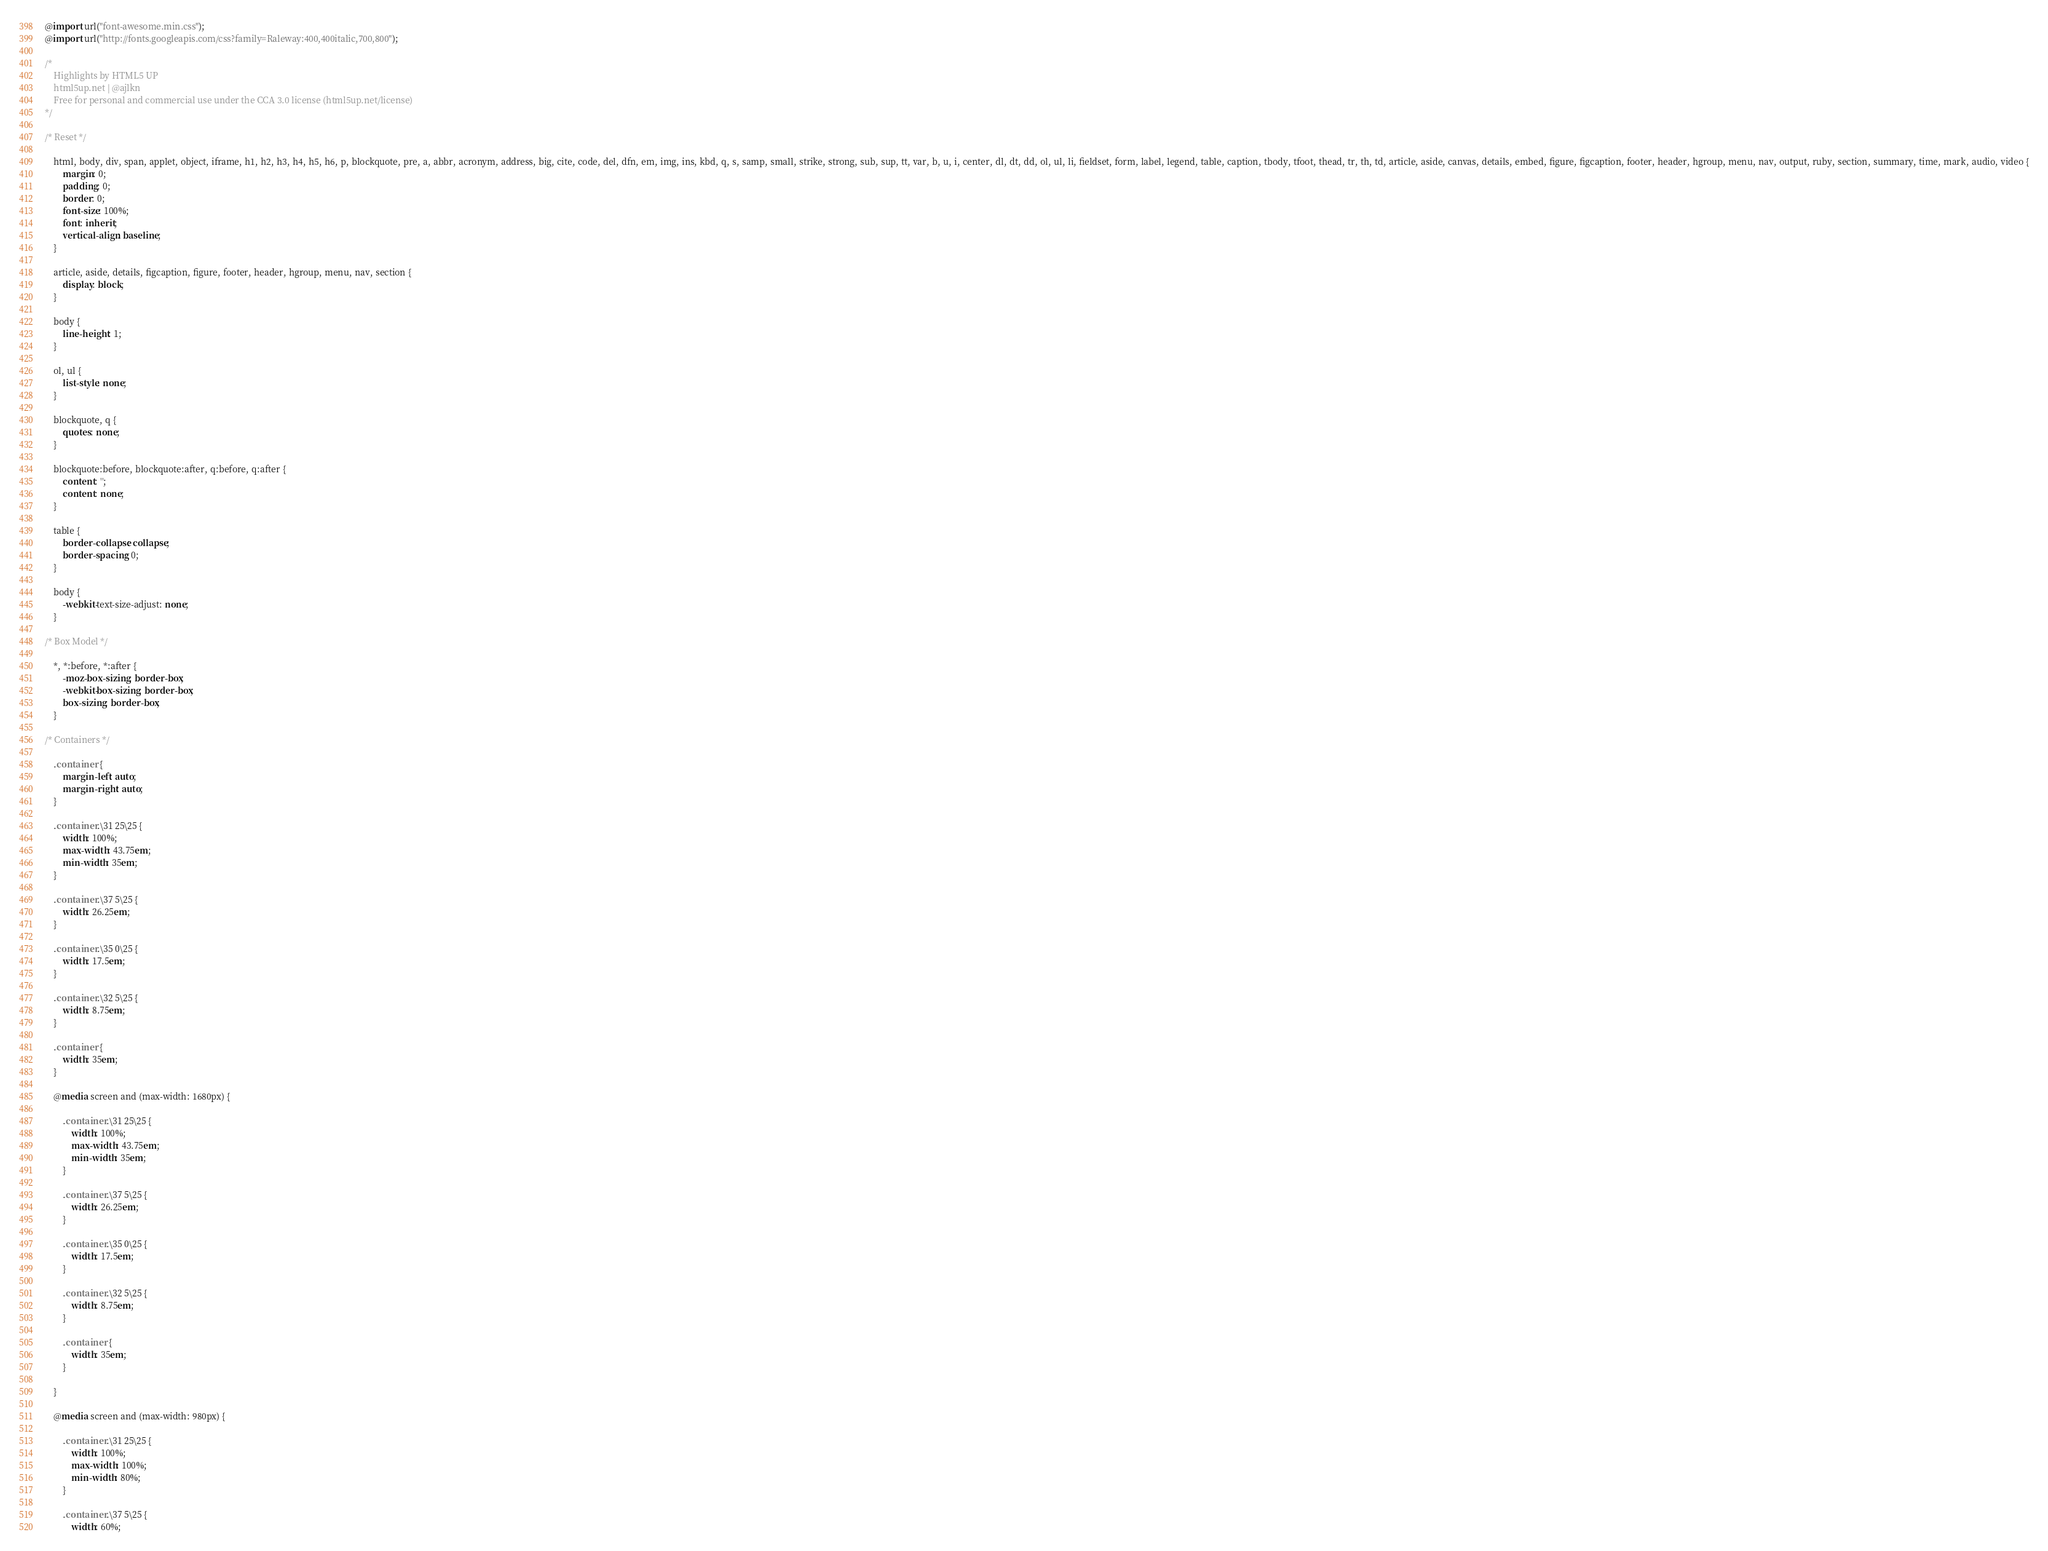Convert code to text. <code><loc_0><loc_0><loc_500><loc_500><_CSS_>@import url("font-awesome.min.css");
@import url("http://fonts.googleapis.com/css?family=Raleway:400,400italic,700,800");

/*
	Highlights by HTML5 UP
	html5up.net | @ajlkn
	Free for personal and commercial use under the CCA 3.0 license (html5up.net/license)
*/

/* Reset */

	html, body, div, span, applet, object, iframe, h1, h2, h3, h4, h5, h6, p, blockquote, pre, a, abbr, acronym, address, big, cite, code, del, dfn, em, img, ins, kbd, q, s, samp, small, strike, strong, sub, sup, tt, var, b, u, i, center, dl, dt, dd, ol, ul, li, fieldset, form, label, legend, table, caption, tbody, tfoot, thead, tr, th, td, article, aside, canvas, details, embed, figure, figcaption, footer, header, hgroup, menu, nav, output, ruby, section, summary, time, mark, audio, video {
		margin: 0;
		padding: 0;
		border: 0;
		font-size: 100%;
		font: inherit;
		vertical-align: baseline;
	}

	article, aside, details, figcaption, figure, footer, header, hgroup, menu, nav, section {
		display: block;
	}

	body {
		line-height: 1;
	}

	ol, ul {
		list-style: none;
	}

	blockquote, q {
		quotes: none;
	}

	blockquote:before, blockquote:after, q:before, q:after {
		content: '';
		content: none;
	}

	table {
		border-collapse: collapse;
		border-spacing: 0;
	}

	body {
		-webkit-text-size-adjust: none;
	}

/* Box Model */

	*, *:before, *:after {
		-moz-box-sizing: border-box;
		-webkit-box-sizing: border-box;
		box-sizing: border-box;
	}

/* Containers */

	.container {
		margin-left: auto;
		margin-right: auto;
	}

	.container.\31 25\25 {
		width: 100%;
		max-width: 43.75em;
		min-width: 35em;
	}

	.container.\37 5\25 {
		width: 26.25em;
	}

	.container.\35 0\25 {
		width: 17.5em;
	}

	.container.\32 5\25 {
		width: 8.75em;
	}

	.container {
		width: 35em;
	}

	@media screen and (max-width: 1680px) {

		.container.\31 25\25 {
			width: 100%;
			max-width: 43.75em;
			min-width: 35em;
		}

		.container.\37 5\25 {
			width: 26.25em;
		}

		.container.\35 0\25 {
			width: 17.5em;
		}

		.container.\32 5\25 {
			width: 8.75em;
		}

		.container {
			width: 35em;
		}

	}

	@media screen and (max-width: 980px) {

		.container.\31 25\25 {
			width: 100%;
			max-width: 100%;
			min-width: 80%;
		}

		.container.\37 5\25 {
			width: 60%;</code> 